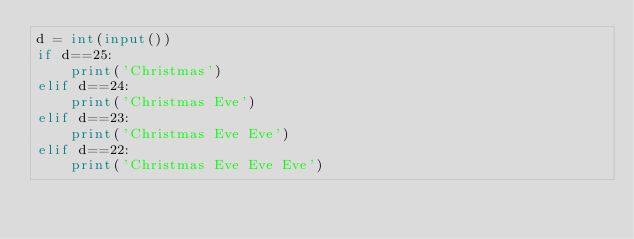Convert code to text. <code><loc_0><loc_0><loc_500><loc_500><_Python_>d = int(input())
if d==25:
    print('Christmas')
elif d==24:
    print('Christmas Eve')
elif d==23:
    print('Christmas Eve Eve')
elif d==22:
    print('Christmas Eve Eve Eve')</code> 